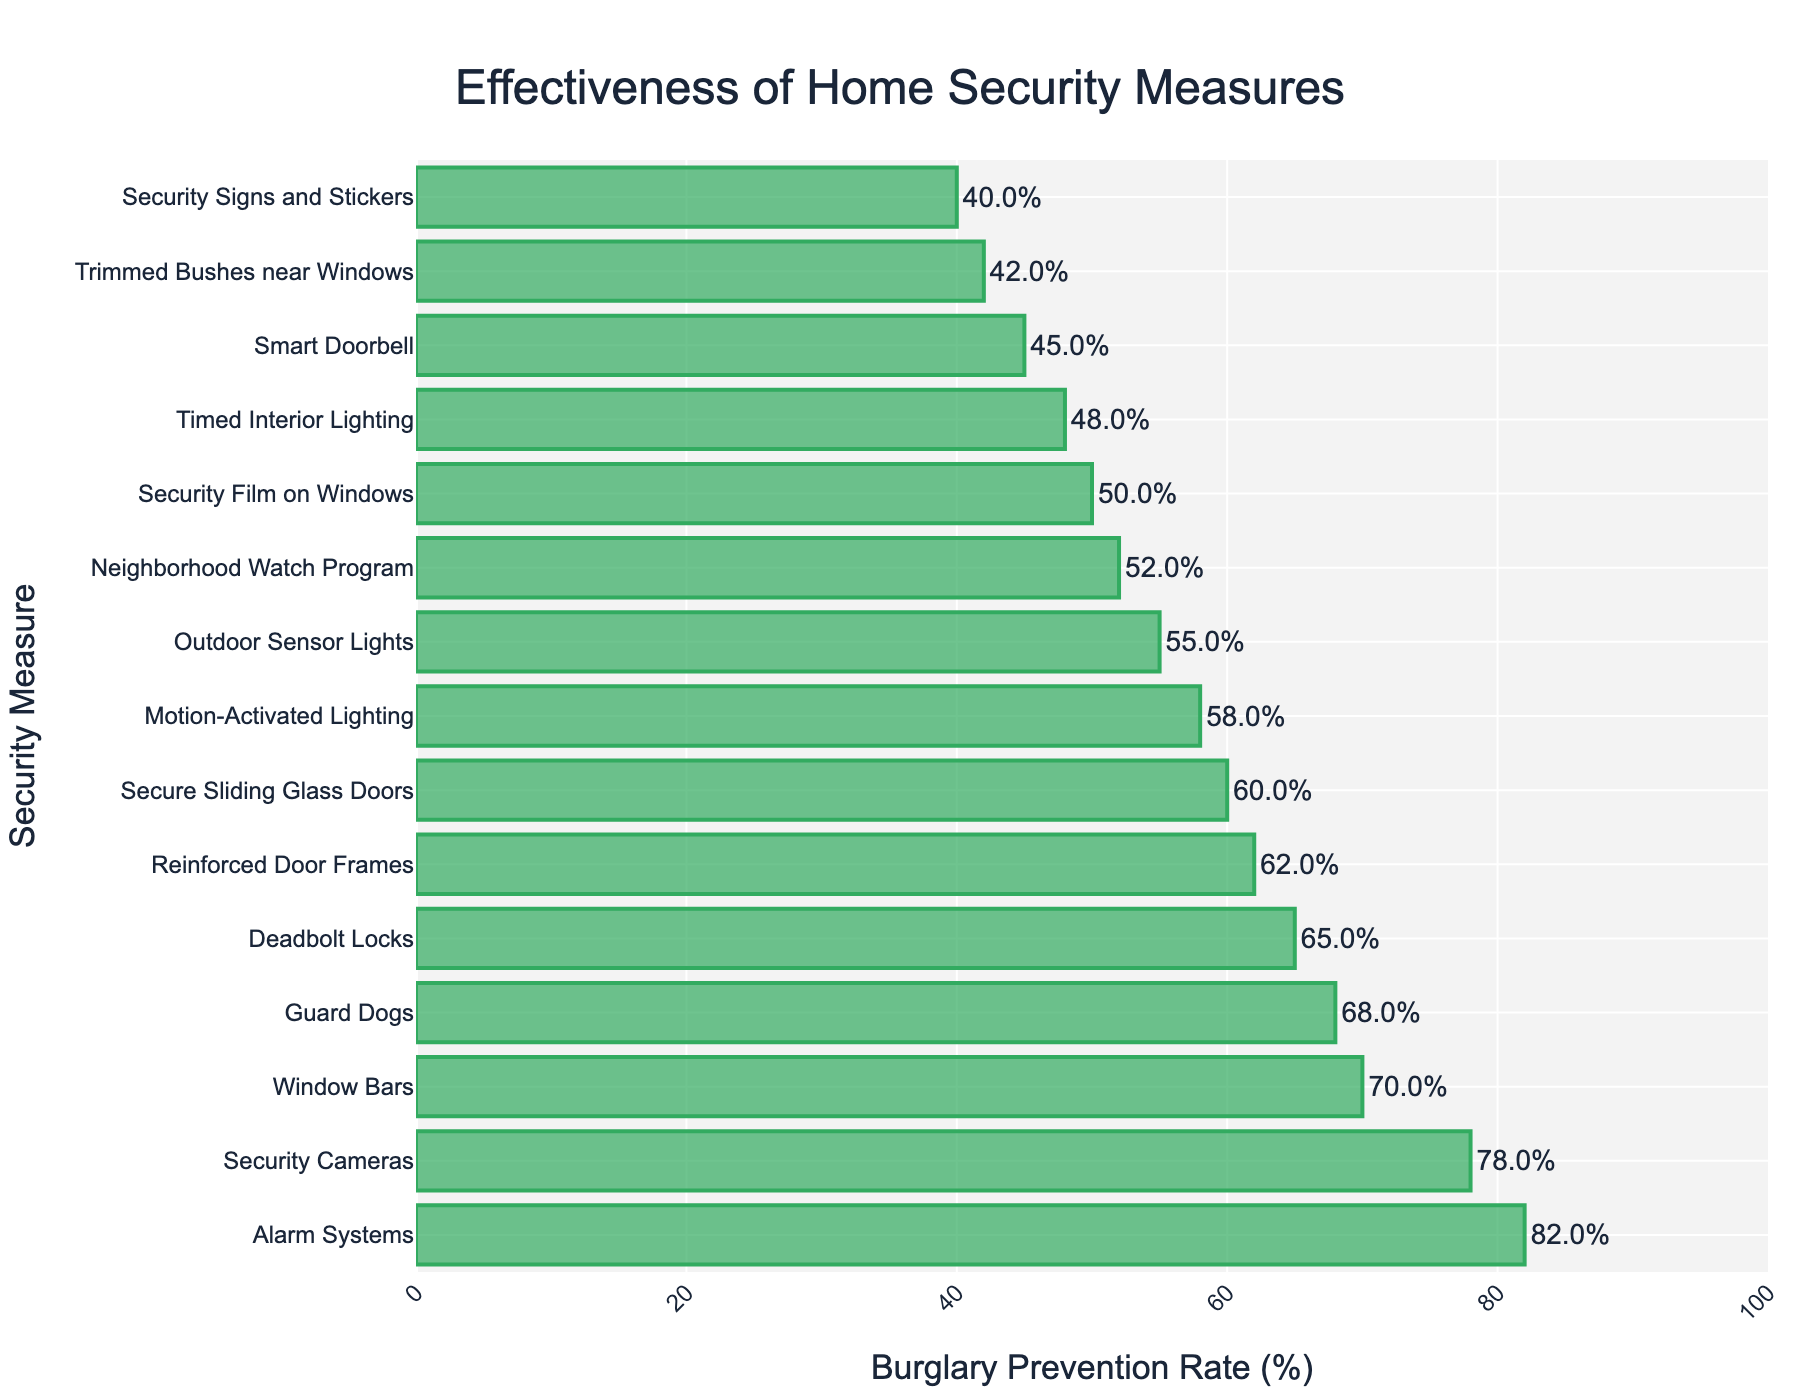What is the most effective home security measure in preventing burglaries? The bar chart shows that the measure with the highest Burglary Prevention Rate is the most effective. The highest rate on the chart is for "Alarm Systems" with a rate of 82%.
Answer: Alarm Systems How much more effective are Security Cameras compared to Security Signs and Stickers? The effectiveness of Security Cameras is 78%, and the effectiveness of Security Signs and Stickers is 40%. Subtracting these values gives the difference in effectiveness. 78% - 40% = 38%.
Answer: 38% Which home security measures have a Burglary Prevention Rate greater than 60%? By examining the bar chart, we can find all measures with rates above 60%. These are "Deadbolt Locks" (65%), "Security Cameras" (78%), "Alarm Systems" (82%), "Window Bars" (70%), "Guard Dogs" (68%), "Reinforced Door Frames" (62%), and "Secure Sliding Glass Doors" (60%).
Answer: Deadbolt Locks, Security Cameras, Alarm Systems, Window Bars, Guard Dogs, Reinforced Door Frames, Secure Sliding Glass Doors Is the effectiveness of having Timed Interior Lighting higher than having Outdoor Sensor Lights? Timed Interior Lighting has an effectiveness rate of 48%, while Outdoor Sensor Lights have an effectiveness rate of 55%. Comparing these values, Outdoor Sensor Lights have a higher rate.
Answer: No What is the median Burglary Prevention Rate among all home security measures? To find the median, we list all the rates in ascending order and find the middle value. The values are: 40, 42, 45, 48, 50, 52, 55, 58, 60, 62, 65, 68, 70, 78, 82. The middle value, and thus the median, is the 8th value in the list, which is 55%.
Answer: 55% Which measure has the lowest Burglary Prevention Rate? The measure with the smallest bar or the lowest value on the y-axis of the bar chart has the lowest rate. This measure is "Security Signs and Stickers" with a rate of 40%.
Answer: Security Signs and Stickers Among Alarm Systems, Security Cameras, and Guard Dogs, which is the least effective? By comparing the heights of their bars or the Burglary Prevention Rates: Alarm Systems (82%), Security Cameras (78%), and Guard Dogs (68%). Guard Dogs have the lowest rate among these three.
Answer: Guard Dogs How does the effectiveness of Motion-Activated Lighting compare to that of Timed Interior Lighting and Security Film on Windows? Motion-Activated Lighting has an effectiveness of 58%, Timed Interior Lighting has 48%, and Security Film on Windows has 50%. Motion-Activated Lighting is more effective than both Timed Interior Lighting (58% vs 48%) and Security Film on Windows (58% vs 50%).
Answer: Motion-Activated Lighting is more effective If we average the effectiveness rates of all security measures starting with the letter 'S', what is the value? First, identify all measures starting with 'S': Security Cameras (78%), Smart Doorbell (45%), Security Signs and Stickers (40%), Secure Sliding Glass Doors (60%), Security Film on Windows (50). Calculate the average: (78% + 45% + 40% + 60% + 50%) / 5 = 273 / 5 = 54.6%.
Answer: 54.6% 